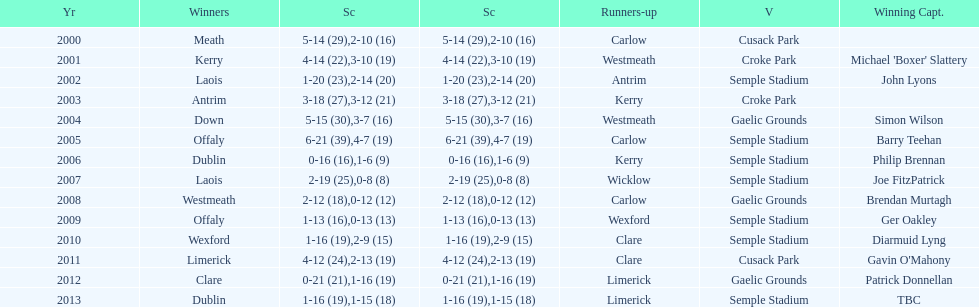Which team was the first to win with a team captain? Kerry. 